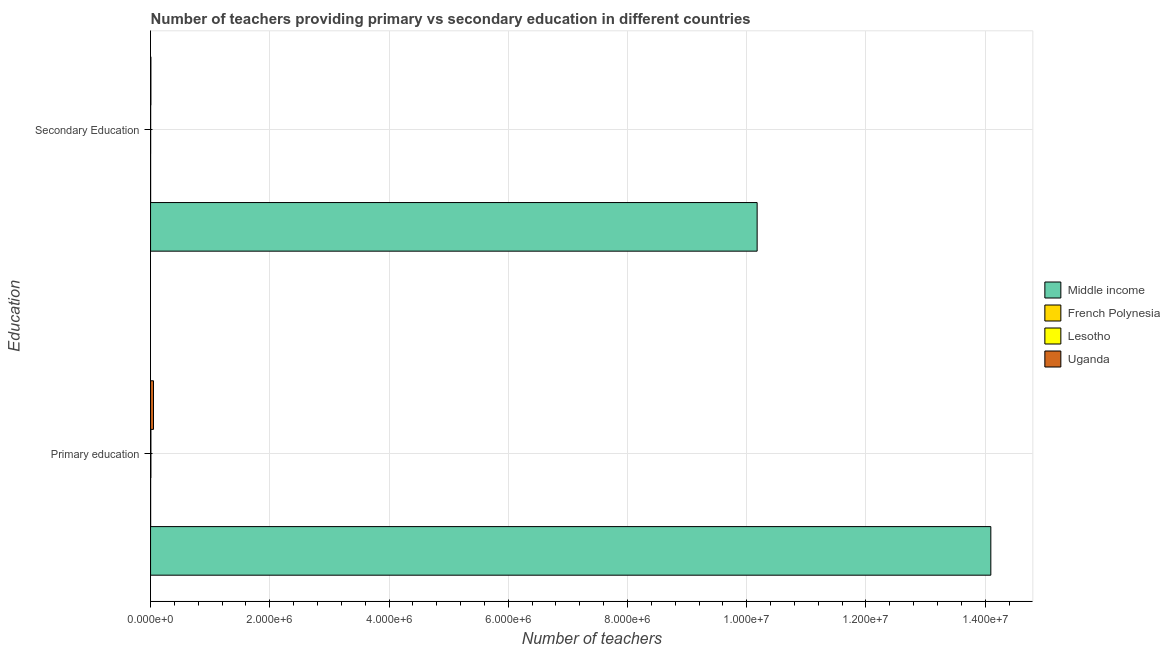How many different coloured bars are there?
Provide a succinct answer. 4. How many groups of bars are there?
Keep it short and to the point. 2. Are the number of bars on each tick of the Y-axis equal?
Your answer should be compact. Yes. How many bars are there on the 1st tick from the bottom?
Offer a very short reply. 4. What is the label of the 1st group of bars from the top?
Offer a terse response. Secondary Education. What is the number of secondary teachers in Lesotho?
Your response must be concise. 1750. Across all countries, what is the maximum number of primary teachers?
Keep it short and to the point. 1.41e+07. Across all countries, what is the minimum number of primary teachers?
Keep it short and to the point. 1361. In which country was the number of secondary teachers maximum?
Offer a very short reply. Middle income. In which country was the number of secondary teachers minimum?
Your answer should be compact. French Polynesia. What is the total number of primary teachers in the graph?
Keep it short and to the point. 1.42e+07. What is the difference between the number of primary teachers in Uganda and that in Lesotho?
Provide a short and direct response. 4.35e+04. What is the difference between the number of primary teachers in Uganda and the number of secondary teachers in French Polynesia?
Your response must be concise. 4.82e+04. What is the average number of primary teachers per country?
Offer a terse response. 3.54e+06. What is the difference between the number of primary teachers and number of secondary teachers in French Polynesia?
Keep it short and to the point. 375. What is the ratio of the number of primary teachers in French Polynesia to that in Lesotho?
Ensure brevity in your answer.  0.24. What does the 3rd bar from the top in Secondary Education represents?
Make the answer very short. French Polynesia. What is the difference between two consecutive major ticks on the X-axis?
Ensure brevity in your answer.  2.00e+06. Are the values on the major ticks of X-axis written in scientific E-notation?
Make the answer very short. Yes. Does the graph contain grids?
Ensure brevity in your answer.  Yes. Where does the legend appear in the graph?
Your response must be concise. Center right. What is the title of the graph?
Give a very brief answer. Number of teachers providing primary vs secondary education in different countries. Does "Aruba" appear as one of the legend labels in the graph?
Provide a succinct answer. No. What is the label or title of the X-axis?
Your answer should be very brief. Number of teachers. What is the label or title of the Y-axis?
Offer a terse response. Education. What is the Number of teachers of Middle income in Primary education?
Ensure brevity in your answer.  1.41e+07. What is the Number of teachers in French Polynesia in Primary education?
Offer a very short reply. 1361. What is the Number of teachers in Lesotho in Primary education?
Give a very brief answer. 5670. What is the Number of teachers of Uganda in Primary education?
Your answer should be compact. 4.92e+04. What is the Number of teachers of Middle income in Secondary Education?
Keep it short and to the point. 1.02e+07. What is the Number of teachers of French Polynesia in Secondary Education?
Offer a very short reply. 986. What is the Number of teachers in Lesotho in Secondary Education?
Your answer should be compact. 1750. What is the Number of teachers in Uganda in Secondary Education?
Make the answer very short. 5617. Across all Education, what is the maximum Number of teachers of Middle income?
Ensure brevity in your answer.  1.41e+07. Across all Education, what is the maximum Number of teachers in French Polynesia?
Keep it short and to the point. 1361. Across all Education, what is the maximum Number of teachers in Lesotho?
Your answer should be very brief. 5670. Across all Education, what is the maximum Number of teachers in Uganda?
Your answer should be very brief. 4.92e+04. Across all Education, what is the minimum Number of teachers of Middle income?
Keep it short and to the point. 1.02e+07. Across all Education, what is the minimum Number of teachers of French Polynesia?
Ensure brevity in your answer.  986. Across all Education, what is the minimum Number of teachers in Lesotho?
Your answer should be very brief. 1750. Across all Education, what is the minimum Number of teachers of Uganda?
Offer a very short reply. 5617. What is the total Number of teachers in Middle income in the graph?
Provide a succinct answer. 2.43e+07. What is the total Number of teachers of French Polynesia in the graph?
Provide a short and direct response. 2347. What is the total Number of teachers of Lesotho in the graph?
Offer a very short reply. 7420. What is the total Number of teachers of Uganda in the graph?
Offer a terse response. 5.48e+04. What is the difference between the Number of teachers of Middle income in Primary education and that in Secondary Education?
Offer a very short reply. 3.92e+06. What is the difference between the Number of teachers in French Polynesia in Primary education and that in Secondary Education?
Make the answer very short. 375. What is the difference between the Number of teachers of Lesotho in Primary education and that in Secondary Education?
Provide a succinct answer. 3920. What is the difference between the Number of teachers of Uganda in Primary education and that in Secondary Education?
Provide a short and direct response. 4.36e+04. What is the difference between the Number of teachers in Middle income in Primary education and the Number of teachers in French Polynesia in Secondary Education?
Offer a very short reply. 1.41e+07. What is the difference between the Number of teachers of Middle income in Primary education and the Number of teachers of Lesotho in Secondary Education?
Offer a very short reply. 1.41e+07. What is the difference between the Number of teachers of Middle income in Primary education and the Number of teachers of Uganda in Secondary Education?
Offer a very short reply. 1.41e+07. What is the difference between the Number of teachers of French Polynesia in Primary education and the Number of teachers of Lesotho in Secondary Education?
Make the answer very short. -389. What is the difference between the Number of teachers in French Polynesia in Primary education and the Number of teachers in Uganda in Secondary Education?
Provide a short and direct response. -4256. What is the average Number of teachers in Middle income per Education?
Provide a short and direct response. 1.21e+07. What is the average Number of teachers in French Polynesia per Education?
Ensure brevity in your answer.  1173.5. What is the average Number of teachers of Lesotho per Education?
Provide a short and direct response. 3710. What is the average Number of teachers of Uganda per Education?
Provide a short and direct response. 2.74e+04. What is the difference between the Number of teachers of Middle income and Number of teachers of French Polynesia in Primary education?
Give a very brief answer. 1.41e+07. What is the difference between the Number of teachers in Middle income and Number of teachers in Lesotho in Primary education?
Your answer should be very brief. 1.41e+07. What is the difference between the Number of teachers in Middle income and Number of teachers in Uganda in Primary education?
Offer a terse response. 1.40e+07. What is the difference between the Number of teachers in French Polynesia and Number of teachers in Lesotho in Primary education?
Your answer should be very brief. -4309. What is the difference between the Number of teachers in French Polynesia and Number of teachers in Uganda in Primary education?
Offer a very short reply. -4.78e+04. What is the difference between the Number of teachers of Lesotho and Number of teachers of Uganda in Primary education?
Ensure brevity in your answer.  -4.35e+04. What is the difference between the Number of teachers in Middle income and Number of teachers in French Polynesia in Secondary Education?
Provide a succinct answer. 1.02e+07. What is the difference between the Number of teachers of Middle income and Number of teachers of Lesotho in Secondary Education?
Offer a very short reply. 1.02e+07. What is the difference between the Number of teachers in Middle income and Number of teachers in Uganda in Secondary Education?
Ensure brevity in your answer.  1.02e+07. What is the difference between the Number of teachers in French Polynesia and Number of teachers in Lesotho in Secondary Education?
Provide a succinct answer. -764. What is the difference between the Number of teachers in French Polynesia and Number of teachers in Uganda in Secondary Education?
Give a very brief answer. -4631. What is the difference between the Number of teachers of Lesotho and Number of teachers of Uganda in Secondary Education?
Offer a terse response. -3867. What is the ratio of the Number of teachers of Middle income in Primary education to that in Secondary Education?
Make the answer very short. 1.39. What is the ratio of the Number of teachers of French Polynesia in Primary education to that in Secondary Education?
Provide a succinct answer. 1.38. What is the ratio of the Number of teachers in Lesotho in Primary education to that in Secondary Education?
Your answer should be very brief. 3.24. What is the ratio of the Number of teachers in Uganda in Primary education to that in Secondary Education?
Ensure brevity in your answer.  8.76. What is the difference between the highest and the second highest Number of teachers in Middle income?
Provide a short and direct response. 3.92e+06. What is the difference between the highest and the second highest Number of teachers in French Polynesia?
Make the answer very short. 375. What is the difference between the highest and the second highest Number of teachers of Lesotho?
Your response must be concise. 3920. What is the difference between the highest and the second highest Number of teachers in Uganda?
Your answer should be compact. 4.36e+04. What is the difference between the highest and the lowest Number of teachers of Middle income?
Your response must be concise. 3.92e+06. What is the difference between the highest and the lowest Number of teachers in French Polynesia?
Provide a succinct answer. 375. What is the difference between the highest and the lowest Number of teachers of Lesotho?
Provide a succinct answer. 3920. What is the difference between the highest and the lowest Number of teachers of Uganda?
Your answer should be very brief. 4.36e+04. 